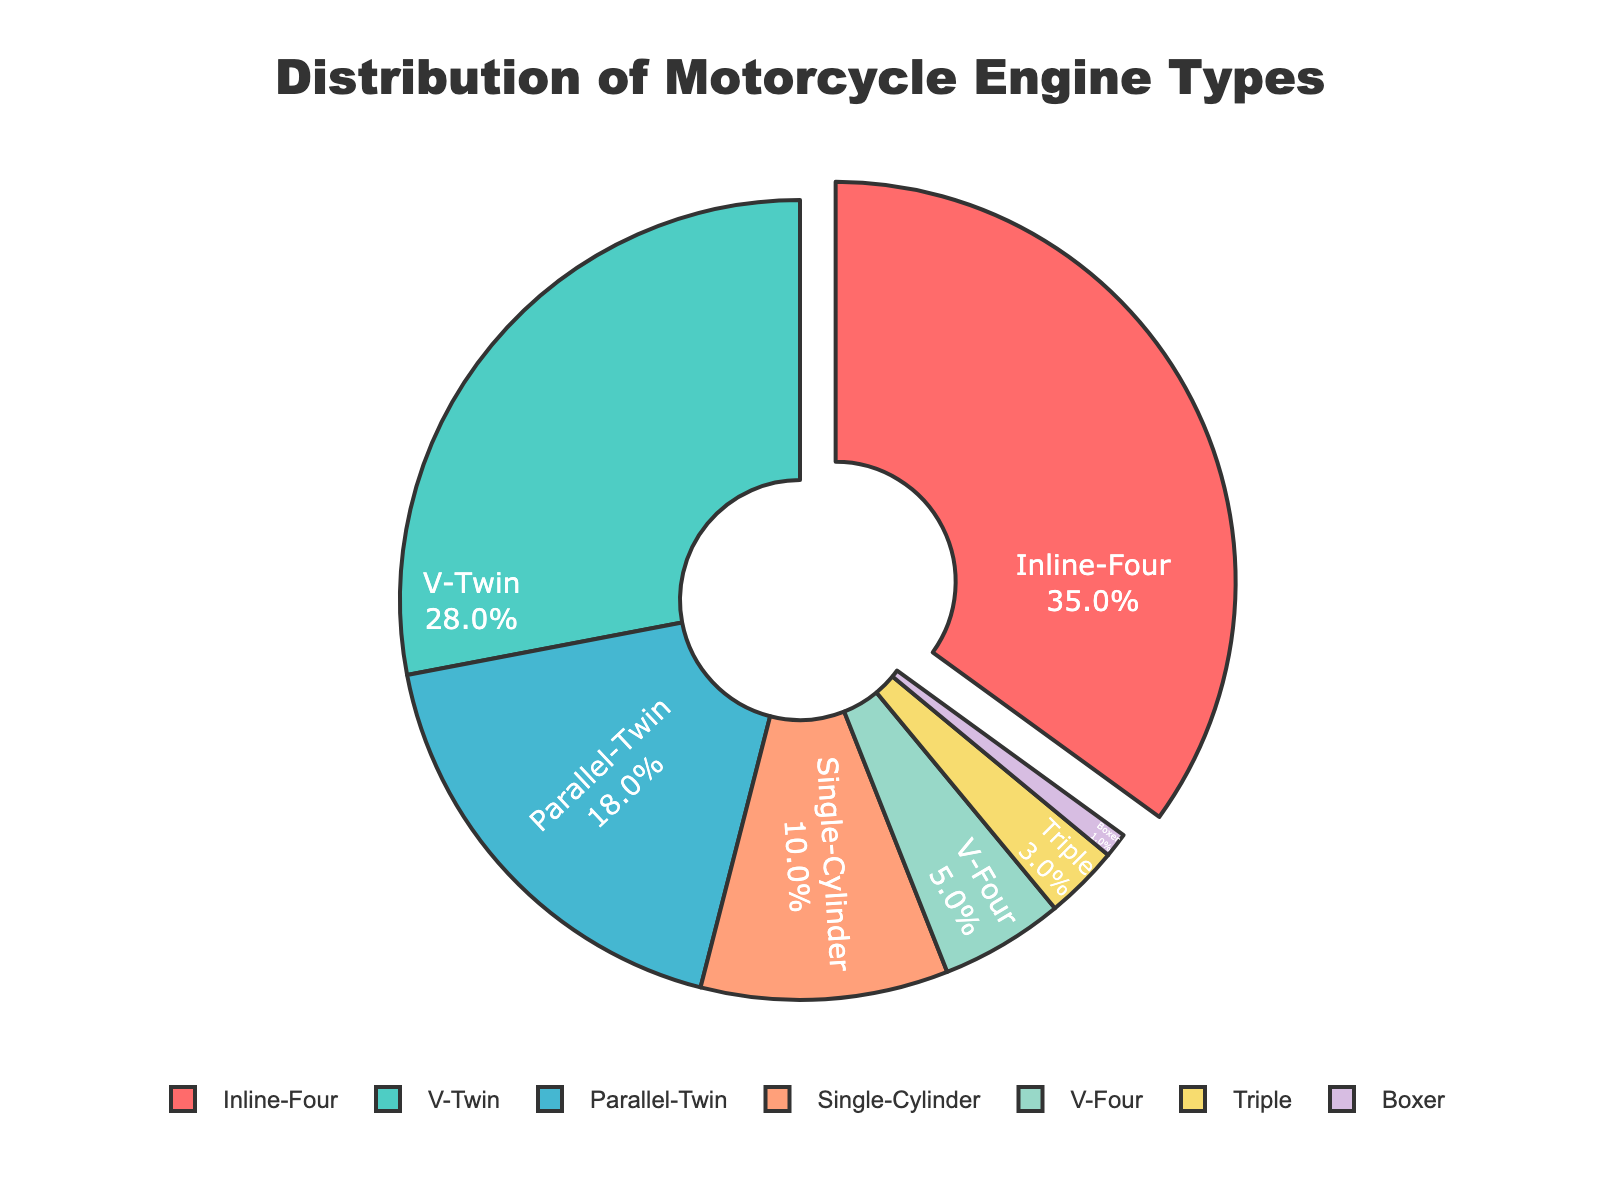Which engine type has the highest percentage? The pie chart shows that the "Inline-Four" engine type occupies the largest segment of the chart. By referring to the values, "Inline-Four" has a percentage of 35%.
Answer: Inline-Four How much more popular is the Inline-Four engine type compared to the V-Twin engine type? By comparing the percentages, the Inline-Four has 35% and the V-Twin has 28%. The difference is calculated as 35% - 28% = 7%.
Answer: 7% What's the combined percentage of Parallel-Twin and Single-Cylinder engine types? To find the combined percentage, we add the values for Parallel-Twin (18%) and Single-Cylinder (10%), which gives us 18% + 10% = 28%.
Answer: 28% Which engine type is the least common among popular models? The pie chart shows the relative sizes of the segments, revealing that the smallest segment is for "Boxer" with 1%.
Answer: Boxer Which engine types collectively make up more than half of the distribution? By evaluating the individual percentages, Inline-Four (35%) and V-Twin (28%) together total 35% + 28% = 63%, which is more than half (i.e., 50%).
Answer: Inline-Four and V-Twin What is the percentage difference between Parallel-Twin and Triple engine types? The Parallel-Twin has a percentage of 18%, while the Triple has 3%. The difference is 18% - 3% = 15%.
Answer: 15% If you were to compare the sum of the percentages of V-Four and Triple to that of Single-Cylinder, what would the result be? The sum of V-Four and Triple is 5% + 3% = 8%. The Single-Cylinder is at 10%. Therefore, the comparison result is 10% (Single-Cylinder) - 8% = 2%.
Answer: 2% Which engine type is nearly three times as popular as the V-Four engine type? The V-Four has a percentage of 5%. Comparing other engine types, the Parallel-Twin at 18% is close to (but not exactly) three times 5%, as 3 × 5% = 15%.
Answer: Parallel-TTwin How do the percentages of V-Twin and V-Four engines compare? The V-Twin has a percentage of 28%, while the V-Four has 5%. Comparing them, 28% is significantly greater than 5%.
Answer: V-Twin is greater What is the difference in percentage points between the most common and least common engine types? The most common type is Inline-Four at 35%, and the least common is Boxer at 1%. The difference is 35% - 1% = 34%.
Answer: 34% Which engine types account for less than 10% of the distribution each? Observing the pie chart, the engine types with less than 10% are V-Four (5%), Triple (3%), and Boxer (1%).
Answer: V-Four, Triple, and Boxer 